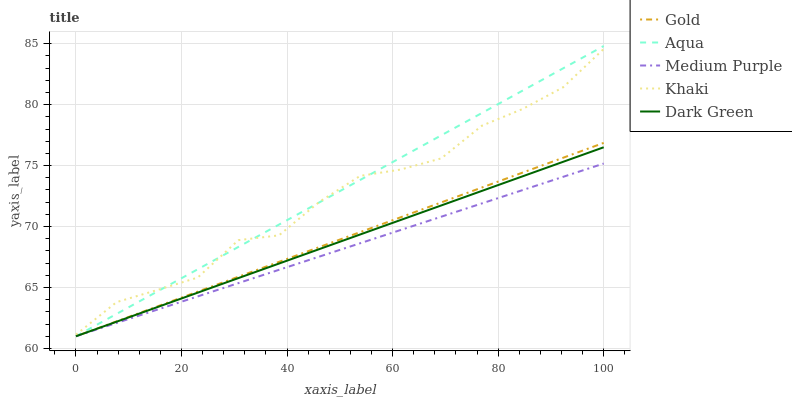Does Medium Purple have the minimum area under the curve?
Answer yes or no. Yes. Does Aqua have the maximum area under the curve?
Answer yes or no. Yes. Does Khaki have the minimum area under the curve?
Answer yes or no. No. Does Khaki have the maximum area under the curve?
Answer yes or no. No. Is Medium Purple the smoothest?
Answer yes or no. Yes. Is Khaki the roughest?
Answer yes or no. Yes. Is Aqua the smoothest?
Answer yes or no. No. Is Aqua the roughest?
Answer yes or no. No. Does Khaki have the lowest value?
Answer yes or no. No. Does Aqua have the highest value?
Answer yes or no. Yes. Does Khaki have the highest value?
Answer yes or no. No. Is Gold less than Khaki?
Answer yes or no. Yes. Is Khaki greater than Dark Green?
Answer yes or no. Yes. Does Gold intersect Dark Green?
Answer yes or no. Yes. Is Gold less than Dark Green?
Answer yes or no. No. Is Gold greater than Dark Green?
Answer yes or no. No. Does Gold intersect Khaki?
Answer yes or no. No. 